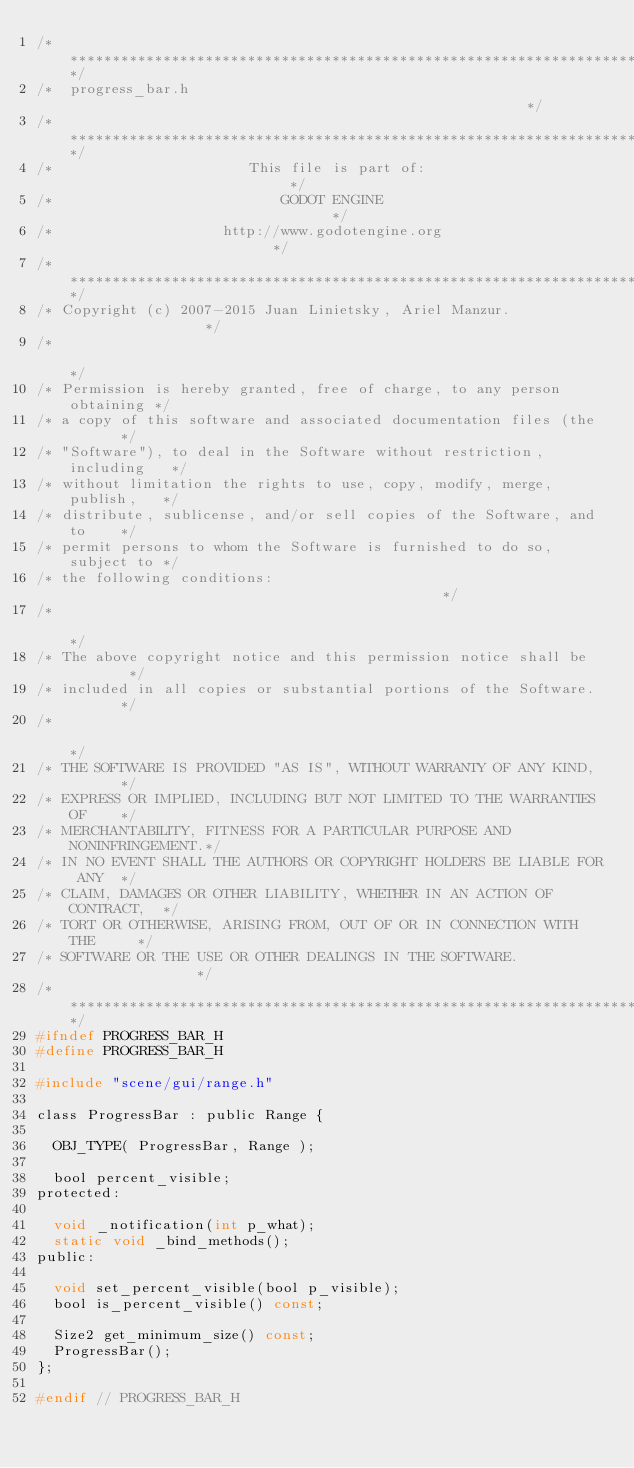<code> <loc_0><loc_0><loc_500><loc_500><_C_>/*************************************************************************/
/*  progress_bar.h                                                       */
/*************************************************************************/
/*                       This file is part of:                           */
/*                           GODOT ENGINE                                */
/*                    http://www.godotengine.org                         */
/*************************************************************************/
/* Copyright (c) 2007-2015 Juan Linietsky, Ariel Manzur.                 */
/*                                                                       */
/* Permission is hereby granted, free of charge, to any person obtaining */
/* a copy of this software and associated documentation files (the       */
/* "Software"), to deal in the Software without restriction, including   */
/* without limitation the rights to use, copy, modify, merge, publish,   */
/* distribute, sublicense, and/or sell copies of the Software, and to    */
/* permit persons to whom the Software is furnished to do so, subject to */
/* the following conditions:                                             */
/*                                                                       */
/* The above copyright notice and this permission notice shall be        */
/* included in all copies or substantial portions of the Software.       */
/*                                                                       */
/* THE SOFTWARE IS PROVIDED "AS IS", WITHOUT WARRANTY OF ANY KIND,       */
/* EXPRESS OR IMPLIED, INCLUDING BUT NOT LIMITED TO THE WARRANTIES OF    */
/* MERCHANTABILITY, FITNESS FOR A PARTICULAR PURPOSE AND NONINFRINGEMENT.*/
/* IN NO EVENT SHALL THE AUTHORS OR COPYRIGHT HOLDERS BE LIABLE FOR ANY  */
/* CLAIM, DAMAGES OR OTHER LIABILITY, WHETHER IN AN ACTION OF CONTRACT,  */
/* TORT OR OTHERWISE, ARISING FROM, OUT OF OR IN CONNECTION WITH THE     */
/* SOFTWARE OR THE USE OR OTHER DEALINGS IN THE SOFTWARE.                */
/*************************************************************************/
#ifndef PROGRESS_BAR_H
#define PROGRESS_BAR_H

#include "scene/gui/range.h"

class ProgressBar : public Range {

	OBJ_TYPE( ProgressBar, Range );

	bool percent_visible;
protected:

	void _notification(int p_what);
	static void _bind_methods();
public:

	void set_percent_visible(bool p_visible);
	bool is_percent_visible() const;

	Size2 get_minimum_size() const;
	ProgressBar();
};

#endif // PROGRESS_BAR_H
</code> 